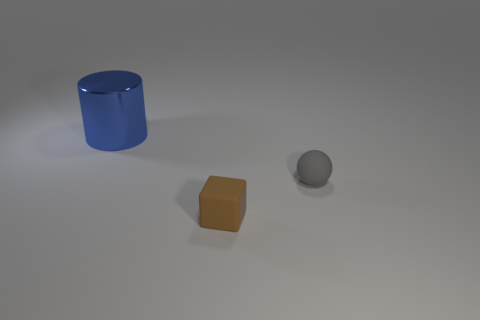How is the lighting in the scene affecting the appearance of the objects? The lighting in the scene appears to be coming from above, casting subtle shadows directly underneath each object, highlighting their shapes and emphasizing their colors with a soft gradient effect. 